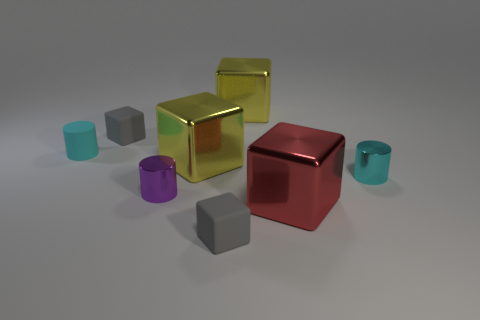Add 1 yellow rubber balls. How many objects exist? 9 Subtract all cylinders. How many objects are left? 5 Subtract all tiny cylinders. Subtract all cyan cylinders. How many objects are left? 3 Add 5 rubber cubes. How many rubber cubes are left? 7 Add 6 tiny purple objects. How many tiny purple objects exist? 7 Subtract 0 cyan balls. How many objects are left? 8 